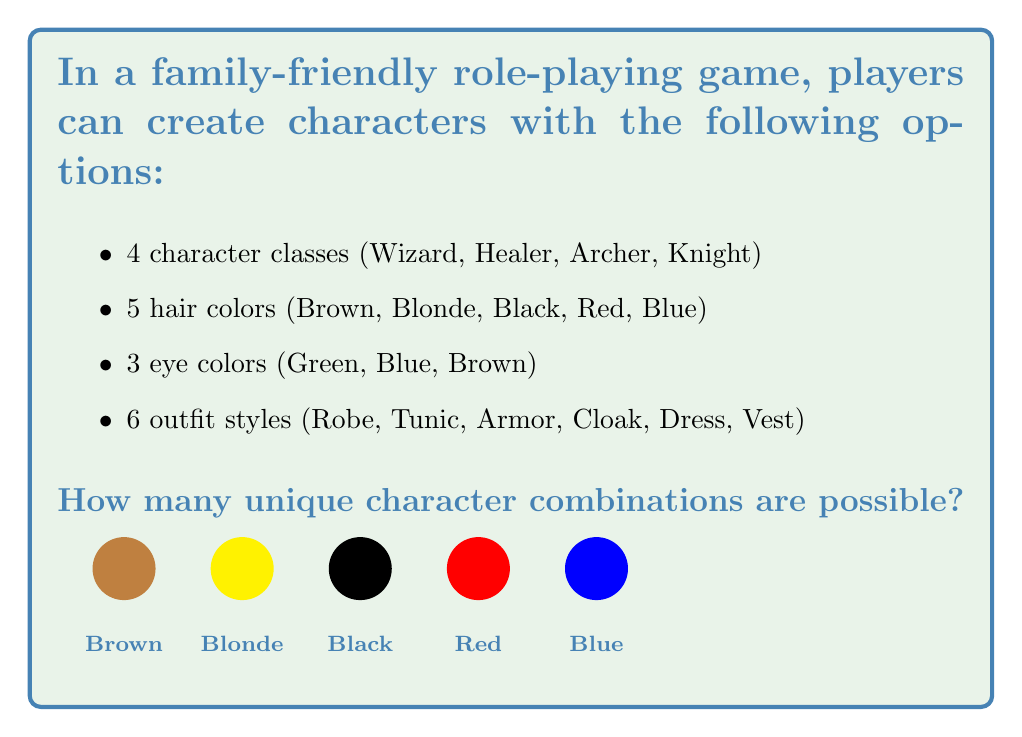Show me your answer to this math problem. To solve this problem, we'll use the fundamental counting principle. This principle states that if we have multiple independent choices, the total number of possible outcomes is the product of the number of possibilities for each choice.

Let's break down the options:
1. Character classes: 4 choices
2. Hair colors: 5 choices
3. Eye colors: 3 choices
4. Outfit styles: 6 choices

Now, let's multiply these numbers together:

$$ \text{Total combinations} = 4 \times 5 \times 3 \times 6 $$

Calculating this:
$$ \text{Total combinations} = 4 \times 5 \times 3 \times 6 = 360 $$

Therefore, there are 360 possible unique character combinations in this family-friendly role-playing game.

This approach ensures that every possible combination of character class, hair color, eye color, and outfit style is accounted for, giving players a wide variety of options to create their unique characters without introducing any violent or inappropriate elements.
Answer: $360$ 